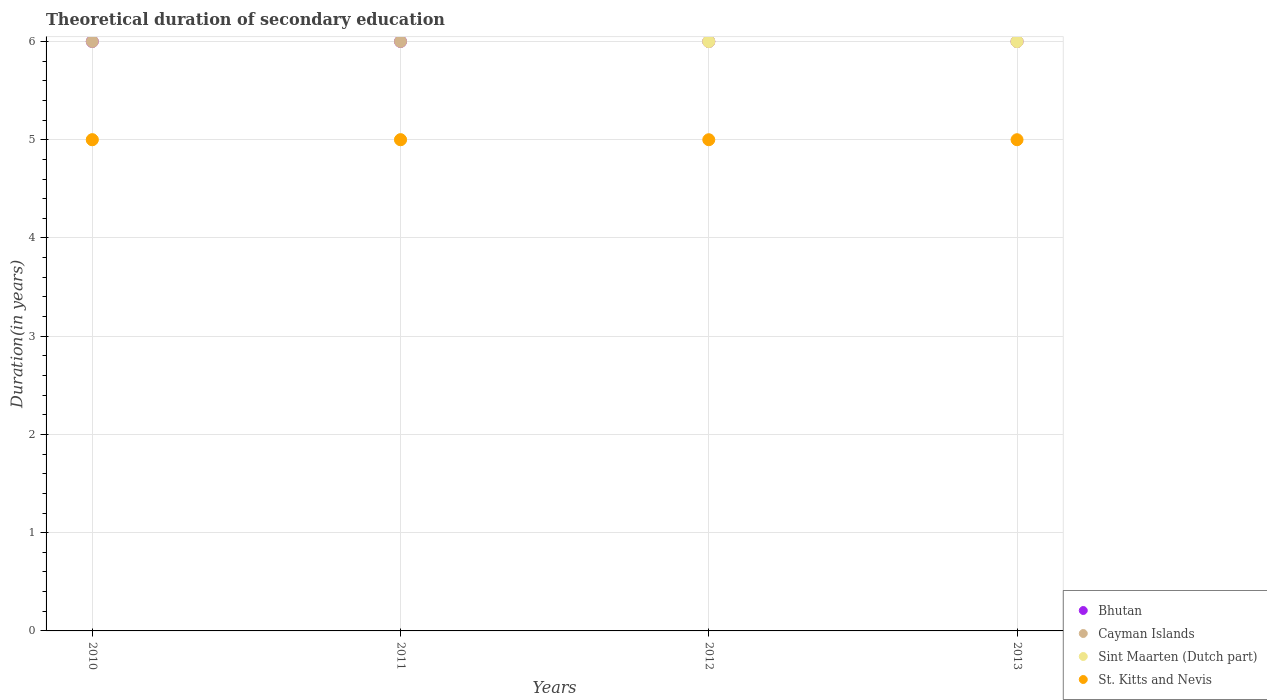Is the number of dotlines equal to the number of legend labels?
Your response must be concise. Yes. What is the total theoretical duration of secondary education in Sint Maarten (Dutch part) in 2012?
Your answer should be compact. 6. Across all years, what is the maximum total theoretical duration of secondary education in Sint Maarten (Dutch part)?
Provide a short and direct response. 6. Across all years, what is the minimum total theoretical duration of secondary education in Sint Maarten (Dutch part)?
Your answer should be very brief. 5. In which year was the total theoretical duration of secondary education in Bhutan minimum?
Your answer should be very brief. 2010. What is the difference between the total theoretical duration of secondary education in St. Kitts and Nevis in 2010 and that in 2013?
Make the answer very short. 0. What is the average total theoretical duration of secondary education in Bhutan per year?
Your response must be concise. 6. In how many years, is the total theoretical duration of secondary education in Bhutan greater than 1.4 years?
Make the answer very short. 4. What is the ratio of the total theoretical duration of secondary education in Bhutan in 2010 to that in 2011?
Offer a terse response. 1. Is the total theoretical duration of secondary education in Sint Maarten (Dutch part) in 2011 less than that in 2013?
Make the answer very short. Yes. Is the difference between the total theoretical duration of secondary education in St. Kitts and Nevis in 2012 and 2013 greater than the difference between the total theoretical duration of secondary education in Sint Maarten (Dutch part) in 2012 and 2013?
Provide a succinct answer. No. In how many years, is the total theoretical duration of secondary education in Sint Maarten (Dutch part) greater than the average total theoretical duration of secondary education in Sint Maarten (Dutch part) taken over all years?
Your answer should be very brief. 2. Does the total theoretical duration of secondary education in Bhutan monotonically increase over the years?
Your response must be concise. No. Is the total theoretical duration of secondary education in St. Kitts and Nevis strictly less than the total theoretical duration of secondary education in Cayman Islands over the years?
Your response must be concise. Yes. How many dotlines are there?
Provide a short and direct response. 4. Are the values on the major ticks of Y-axis written in scientific E-notation?
Your answer should be very brief. No. Does the graph contain any zero values?
Offer a very short reply. No. Does the graph contain grids?
Provide a short and direct response. Yes. Where does the legend appear in the graph?
Your answer should be compact. Bottom right. What is the title of the graph?
Offer a terse response. Theoretical duration of secondary education. Does "Rwanda" appear as one of the legend labels in the graph?
Your answer should be compact. No. What is the label or title of the Y-axis?
Give a very brief answer. Duration(in years). What is the Duration(in years) in Cayman Islands in 2010?
Keep it short and to the point. 6. What is the Duration(in years) of Bhutan in 2011?
Keep it short and to the point. 6. What is the Duration(in years) of Cayman Islands in 2011?
Your answer should be very brief. 6. What is the Duration(in years) in Sint Maarten (Dutch part) in 2012?
Your answer should be very brief. 6. What is the Duration(in years) in Bhutan in 2013?
Offer a very short reply. 6. What is the Duration(in years) in St. Kitts and Nevis in 2013?
Offer a terse response. 5. Across all years, what is the maximum Duration(in years) in Cayman Islands?
Make the answer very short. 6. Across all years, what is the minimum Duration(in years) in Cayman Islands?
Your response must be concise. 6. Across all years, what is the minimum Duration(in years) of St. Kitts and Nevis?
Give a very brief answer. 5. What is the total Duration(in years) of Sint Maarten (Dutch part) in the graph?
Keep it short and to the point. 22. What is the difference between the Duration(in years) of Bhutan in 2010 and that in 2011?
Give a very brief answer. 0. What is the difference between the Duration(in years) of St. Kitts and Nevis in 2010 and that in 2011?
Your answer should be compact. 0. What is the difference between the Duration(in years) in Bhutan in 2010 and that in 2012?
Your answer should be very brief. 0. What is the difference between the Duration(in years) in Cayman Islands in 2010 and that in 2012?
Ensure brevity in your answer.  0. What is the difference between the Duration(in years) of Sint Maarten (Dutch part) in 2010 and that in 2012?
Ensure brevity in your answer.  -1. What is the difference between the Duration(in years) of St. Kitts and Nevis in 2010 and that in 2012?
Give a very brief answer. 0. What is the difference between the Duration(in years) of Cayman Islands in 2010 and that in 2013?
Offer a terse response. 0. What is the difference between the Duration(in years) in Sint Maarten (Dutch part) in 2010 and that in 2013?
Keep it short and to the point. -1. What is the difference between the Duration(in years) of St. Kitts and Nevis in 2010 and that in 2013?
Your response must be concise. 0. What is the difference between the Duration(in years) in Bhutan in 2011 and that in 2012?
Offer a very short reply. 0. What is the difference between the Duration(in years) of Sint Maarten (Dutch part) in 2011 and that in 2012?
Your response must be concise. -1. What is the difference between the Duration(in years) in Bhutan in 2011 and that in 2013?
Give a very brief answer. 0. What is the difference between the Duration(in years) of Cayman Islands in 2011 and that in 2013?
Your answer should be compact. 0. What is the difference between the Duration(in years) of Cayman Islands in 2012 and that in 2013?
Provide a short and direct response. 0. What is the difference between the Duration(in years) in Sint Maarten (Dutch part) in 2012 and that in 2013?
Provide a succinct answer. 0. What is the difference between the Duration(in years) in St. Kitts and Nevis in 2012 and that in 2013?
Give a very brief answer. 0. What is the difference between the Duration(in years) of Bhutan in 2010 and the Duration(in years) of Cayman Islands in 2011?
Keep it short and to the point. 0. What is the difference between the Duration(in years) in Bhutan in 2010 and the Duration(in years) in Sint Maarten (Dutch part) in 2011?
Provide a short and direct response. 1. What is the difference between the Duration(in years) in Cayman Islands in 2010 and the Duration(in years) in Sint Maarten (Dutch part) in 2011?
Your response must be concise. 1. What is the difference between the Duration(in years) of Cayman Islands in 2010 and the Duration(in years) of St. Kitts and Nevis in 2011?
Provide a short and direct response. 1. What is the difference between the Duration(in years) in Bhutan in 2010 and the Duration(in years) in Cayman Islands in 2012?
Provide a succinct answer. 0. What is the difference between the Duration(in years) in Bhutan in 2010 and the Duration(in years) in Sint Maarten (Dutch part) in 2012?
Make the answer very short. 0. What is the difference between the Duration(in years) of Bhutan in 2010 and the Duration(in years) of St. Kitts and Nevis in 2012?
Keep it short and to the point. 1. What is the difference between the Duration(in years) in Cayman Islands in 2010 and the Duration(in years) in Sint Maarten (Dutch part) in 2012?
Provide a short and direct response. 0. What is the difference between the Duration(in years) of Cayman Islands in 2010 and the Duration(in years) of St. Kitts and Nevis in 2012?
Your answer should be very brief. 1. What is the difference between the Duration(in years) of Bhutan in 2010 and the Duration(in years) of Cayman Islands in 2013?
Your answer should be very brief. 0. What is the difference between the Duration(in years) in Bhutan in 2010 and the Duration(in years) in Sint Maarten (Dutch part) in 2013?
Provide a succinct answer. 0. What is the difference between the Duration(in years) of Bhutan in 2010 and the Duration(in years) of St. Kitts and Nevis in 2013?
Your answer should be very brief. 1. What is the difference between the Duration(in years) in Cayman Islands in 2010 and the Duration(in years) in Sint Maarten (Dutch part) in 2013?
Provide a short and direct response. 0. What is the difference between the Duration(in years) of Sint Maarten (Dutch part) in 2010 and the Duration(in years) of St. Kitts and Nevis in 2013?
Make the answer very short. 0. What is the difference between the Duration(in years) of Bhutan in 2011 and the Duration(in years) of Cayman Islands in 2012?
Offer a terse response. 0. What is the difference between the Duration(in years) of Bhutan in 2011 and the Duration(in years) of Sint Maarten (Dutch part) in 2012?
Provide a short and direct response. 0. What is the difference between the Duration(in years) of Cayman Islands in 2011 and the Duration(in years) of St. Kitts and Nevis in 2012?
Your answer should be compact. 1. What is the difference between the Duration(in years) in Sint Maarten (Dutch part) in 2011 and the Duration(in years) in St. Kitts and Nevis in 2012?
Provide a short and direct response. 0. What is the difference between the Duration(in years) in Bhutan in 2011 and the Duration(in years) in Cayman Islands in 2013?
Give a very brief answer. 0. What is the difference between the Duration(in years) in Cayman Islands in 2011 and the Duration(in years) in Sint Maarten (Dutch part) in 2013?
Your answer should be very brief. 0. What is the difference between the Duration(in years) of Cayman Islands in 2011 and the Duration(in years) of St. Kitts and Nevis in 2013?
Give a very brief answer. 1. What is the difference between the Duration(in years) in Sint Maarten (Dutch part) in 2011 and the Duration(in years) in St. Kitts and Nevis in 2013?
Provide a succinct answer. 0. What is the difference between the Duration(in years) of Bhutan in 2012 and the Duration(in years) of Sint Maarten (Dutch part) in 2013?
Ensure brevity in your answer.  0. What is the difference between the Duration(in years) of Bhutan in 2012 and the Duration(in years) of St. Kitts and Nevis in 2013?
Provide a succinct answer. 1. What is the difference between the Duration(in years) of Cayman Islands in 2012 and the Duration(in years) of St. Kitts and Nevis in 2013?
Give a very brief answer. 1. What is the difference between the Duration(in years) in Sint Maarten (Dutch part) in 2012 and the Duration(in years) in St. Kitts and Nevis in 2013?
Give a very brief answer. 1. What is the average Duration(in years) of Cayman Islands per year?
Provide a succinct answer. 6. What is the average Duration(in years) of Sint Maarten (Dutch part) per year?
Provide a succinct answer. 5.5. In the year 2010, what is the difference between the Duration(in years) of Sint Maarten (Dutch part) and Duration(in years) of St. Kitts and Nevis?
Your answer should be very brief. 0. In the year 2011, what is the difference between the Duration(in years) of Bhutan and Duration(in years) of Sint Maarten (Dutch part)?
Your response must be concise. 1. In the year 2011, what is the difference between the Duration(in years) in Cayman Islands and Duration(in years) in Sint Maarten (Dutch part)?
Keep it short and to the point. 1. In the year 2012, what is the difference between the Duration(in years) in Bhutan and Duration(in years) in Cayman Islands?
Provide a succinct answer. 0. In the year 2012, what is the difference between the Duration(in years) in Bhutan and Duration(in years) in St. Kitts and Nevis?
Provide a short and direct response. 1. In the year 2012, what is the difference between the Duration(in years) of Cayman Islands and Duration(in years) of Sint Maarten (Dutch part)?
Provide a succinct answer. 0. In the year 2013, what is the difference between the Duration(in years) of Cayman Islands and Duration(in years) of Sint Maarten (Dutch part)?
Ensure brevity in your answer.  0. In the year 2013, what is the difference between the Duration(in years) in Cayman Islands and Duration(in years) in St. Kitts and Nevis?
Keep it short and to the point. 1. In the year 2013, what is the difference between the Duration(in years) in Sint Maarten (Dutch part) and Duration(in years) in St. Kitts and Nevis?
Your response must be concise. 1. What is the ratio of the Duration(in years) in Bhutan in 2010 to that in 2011?
Make the answer very short. 1. What is the ratio of the Duration(in years) of Cayman Islands in 2010 to that in 2011?
Your answer should be very brief. 1. What is the ratio of the Duration(in years) of Sint Maarten (Dutch part) in 2010 to that in 2012?
Offer a very short reply. 0.83. What is the ratio of the Duration(in years) in St. Kitts and Nevis in 2010 to that in 2012?
Ensure brevity in your answer.  1. What is the ratio of the Duration(in years) of Sint Maarten (Dutch part) in 2010 to that in 2013?
Your response must be concise. 0.83. What is the ratio of the Duration(in years) of St. Kitts and Nevis in 2010 to that in 2013?
Provide a short and direct response. 1. What is the ratio of the Duration(in years) in Bhutan in 2011 to that in 2012?
Make the answer very short. 1. What is the ratio of the Duration(in years) of Cayman Islands in 2011 to that in 2012?
Provide a short and direct response. 1. What is the ratio of the Duration(in years) of Sint Maarten (Dutch part) in 2011 to that in 2012?
Your answer should be compact. 0.83. What is the ratio of the Duration(in years) in St. Kitts and Nevis in 2011 to that in 2012?
Your answer should be compact. 1. What is the ratio of the Duration(in years) in Sint Maarten (Dutch part) in 2011 to that in 2013?
Make the answer very short. 0.83. What is the ratio of the Duration(in years) of Cayman Islands in 2012 to that in 2013?
Make the answer very short. 1. What is the ratio of the Duration(in years) in Sint Maarten (Dutch part) in 2012 to that in 2013?
Offer a terse response. 1. What is the ratio of the Duration(in years) of St. Kitts and Nevis in 2012 to that in 2013?
Offer a terse response. 1. What is the difference between the highest and the second highest Duration(in years) of Cayman Islands?
Provide a succinct answer. 0. What is the difference between the highest and the lowest Duration(in years) in Bhutan?
Provide a short and direct response. 0. What is the difference between the highest and the lowest Duration(in years) in Cayman Islands?
Offer a very short reply. 0. What is the difference between the highest and the lowest Duration(in years) in Sint Maarten (Dutch part)?
Keep it short and to the point. 1. What is the difference between the highest and the lowest Duration(in years) in St. Kitts and Nevis?
Your answer should be very brief. 0. 